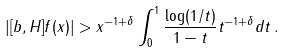Convert formula to latex. <formula><loc_0><loc_0><loc_500><loc_500>| [ b , H ] f ( x ) | > x ^ { - 1 + \delta } \int _ { 0 } ^ { 1 } \frac { \log ( 1 / t ) } { 1 - t } t ^ { - 1 + \delta } d t \, .</formula> 